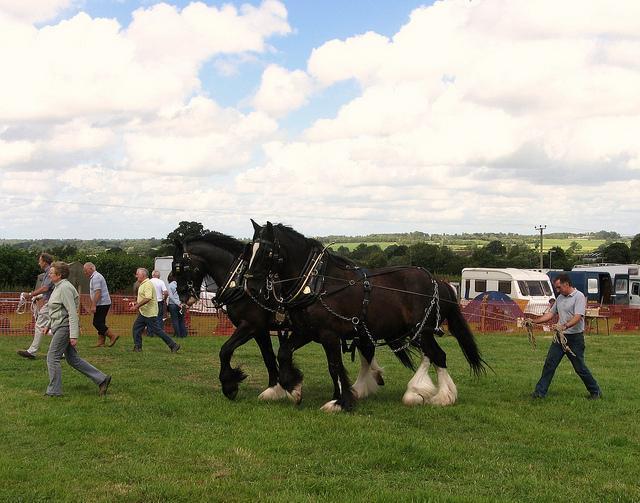Where can the people potentially sleep?
Select the accurate answer and provide explanation: 'Answer: answer
Rationale: rationale.'
Options: Car, trailer, field, horse. Answer: trailer.
Rationale: You can't sleep on a horse. you need some sort of shelter and a trailer is the appropriate size, a car is too small. sleeping in the field offers no shelter. 